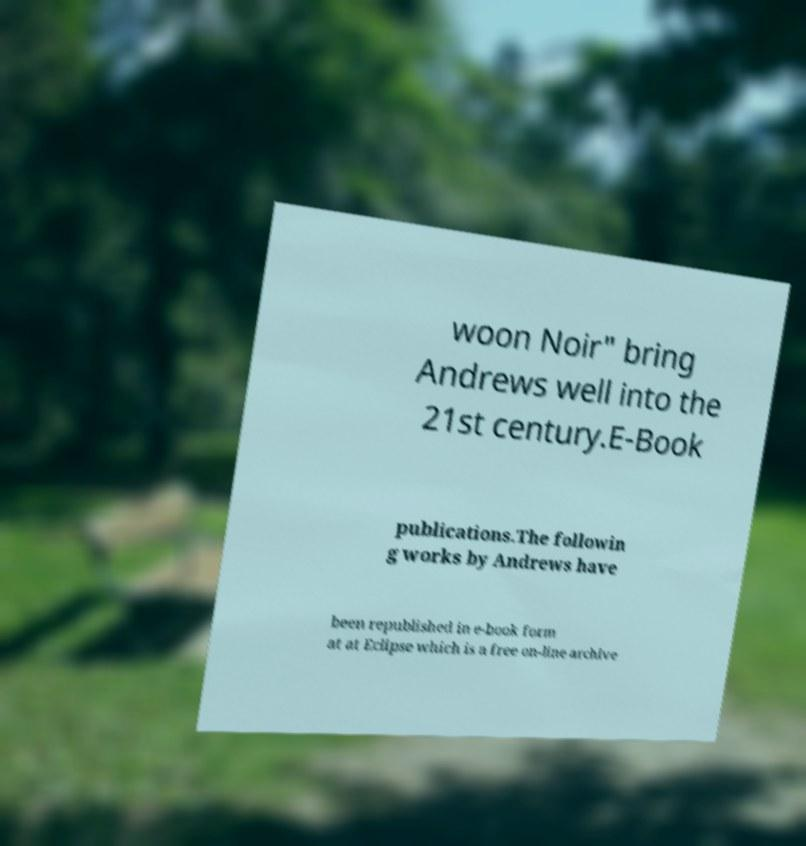Can you accurately transcribe the text from the provided image for me? woon Noir" bring Andrews well into the 21st century.E-Book publications.The followin g works by Andrews have been republished in e-book form at at Eclipse which is a free on-line archive 